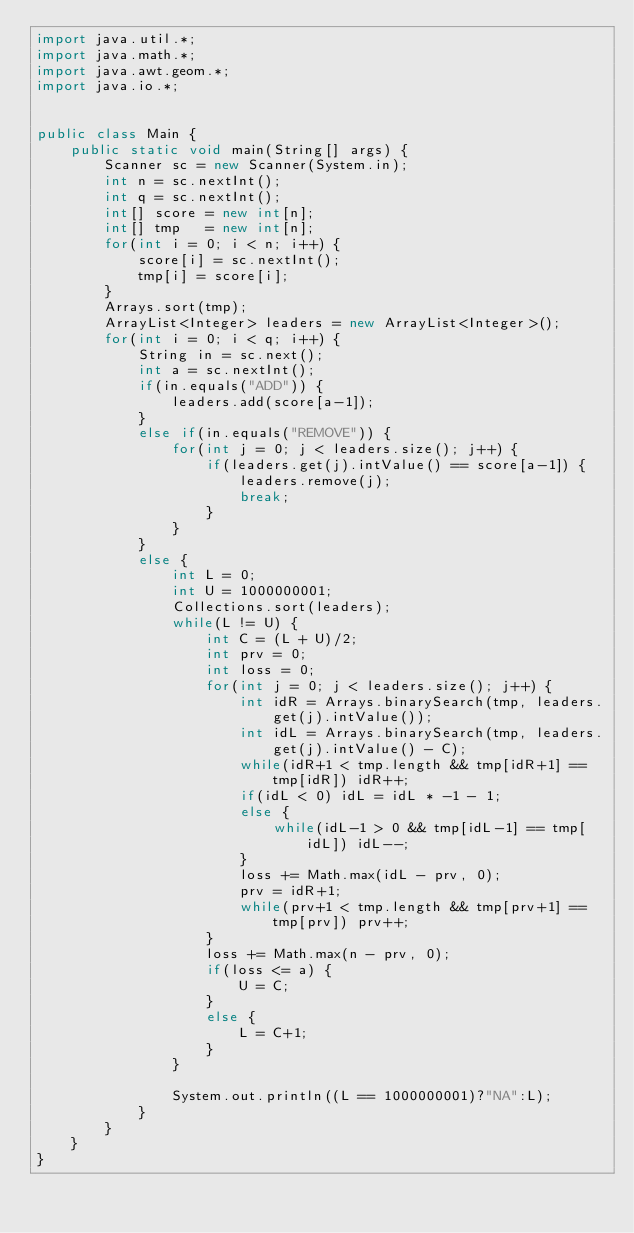<code> <loc_0><loc_0><loc_500><loc_500><_Java_>import java.util.*;
import java.math.*;
import java.awt.geom.*;
import java.io.*;
    
    
public class Main {
	public static void main(String[] args) {
		Scanner sc = new Scanner(System.in);
		int n = sc.nextInt();
		int q = sc.nextInt();
		int[] score = new int[n];
		int[] tmp   = new int[n];
		for(int i = 0; i < n; i++) {
			score[i] = sc.nextInt();
			tmp[i] = score[i];
		}
		Arrays.sort(tmp);
		ArrayList<Integer> leaders = new ArrayList<Integer>();
		for(int i = 0; i < q; i++) {
			String in = sc.next();
			int a = sc.nextInt();
			if(in.equals("ADD")) {
				leaders.add(score[a-1]);
			}
			else if(in.equals("REMOVE")) {
				for(int j = 0; j < leaders.size(); j++) {
					if(leaders.get(j).intValue() == score[a-1]) {
						leaders.remove(j);
						break;
					}
				}
			}
			else {
				int L = 0;
				int U = 1000000001;
				Collections.sort(leaders);
				while(L != U) {
					int C = (L + U)/2;
					int prv = 0;
					int loss = 0;
					for(int j = 0; j < leaders.size(); j++) {
						int idR = Arrays.binarySearch(tmp, leaders.get(j).intValue());
						int idL = Arrays.binarySearch(tmp, leaders.get(j).intValue() - C);
						while(idR+1 < tmp.length && tmp[idR+1] == tmp[idR]) idR++;
						if(idL < 0) idL = idL * -1 - 1;
						else {
							while(idL-1 > 0 && tmp[idL-1] == tmp[idL]) idL--;
						}
						loss += Math.max(idL - prv, 0);
						prv = idR+1;
						while(prv+1 < tmp.length && tmp[prv+1] == tmp[prv]) prv++;
					}
					loss += Math.max(n - prv, 0);
					if(loss <= a) {
						U = C;
					}
					else {
						L = C+1;
					}	
				}
				
				System.out.println((L == 1000000001)?"NA":L);
			}
		}
	}
}</code> 